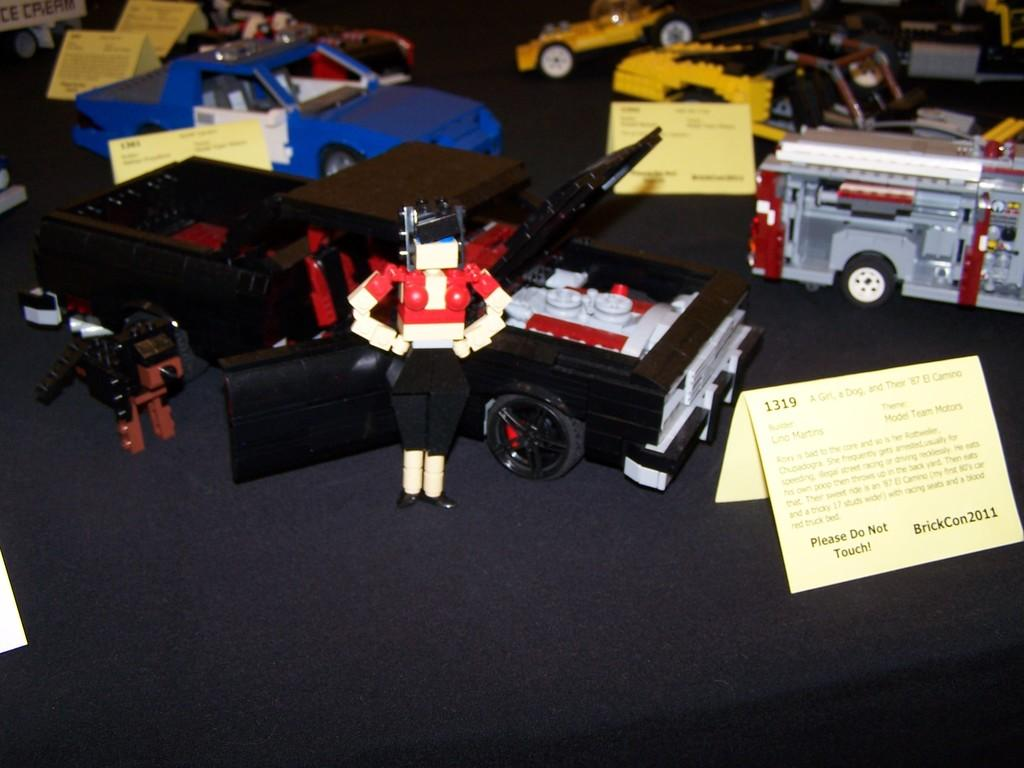Provide a one-sentence caption for the provided image. A display with a sign stating Please Do Not Touch!. 